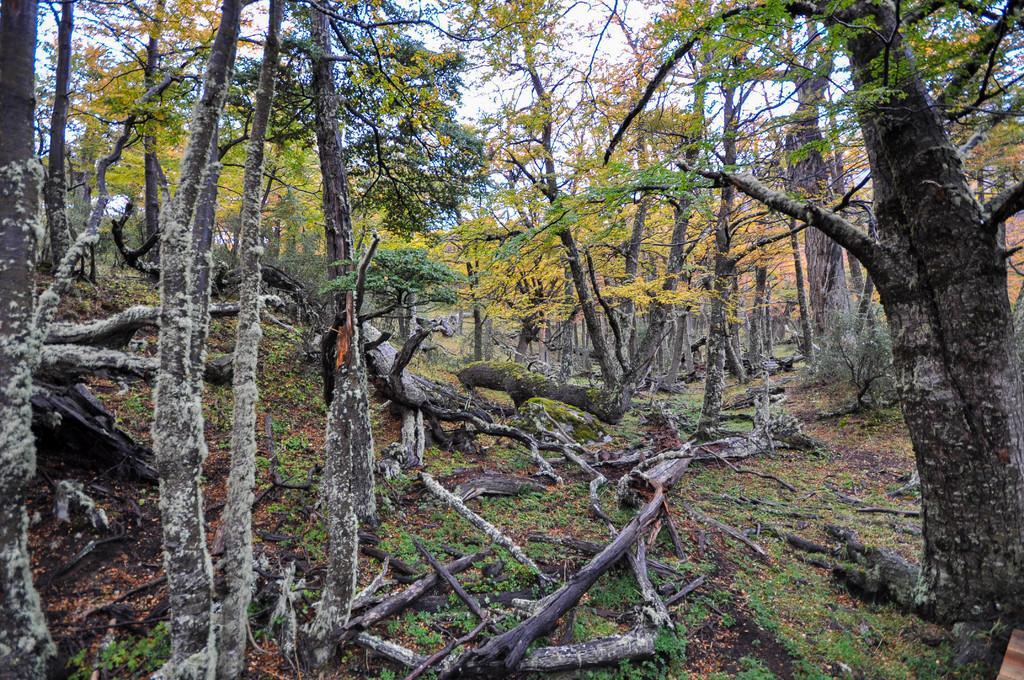Can you describe this image briefly? In this pictures I can see few trees and few tree barks on the ground and a cloudy Sky. 